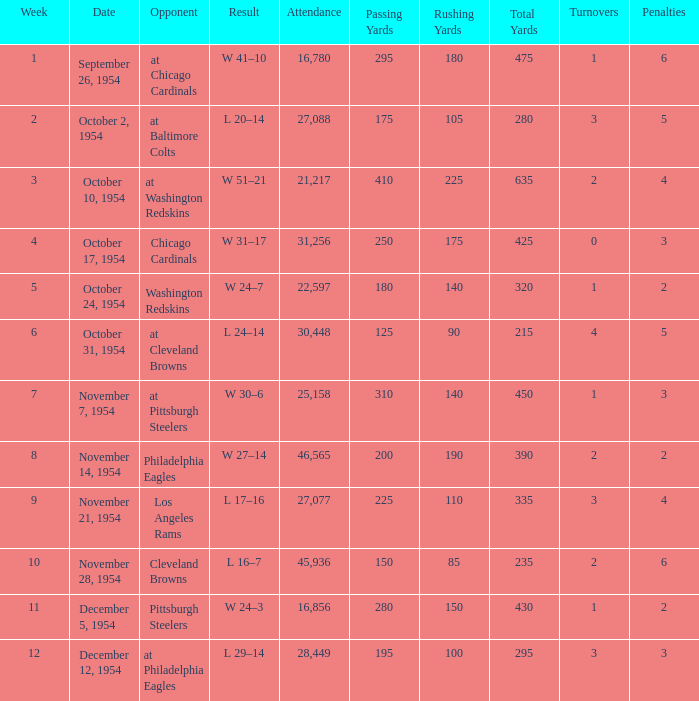How many weeks have october 31, 1954 as the date? 1.0. 